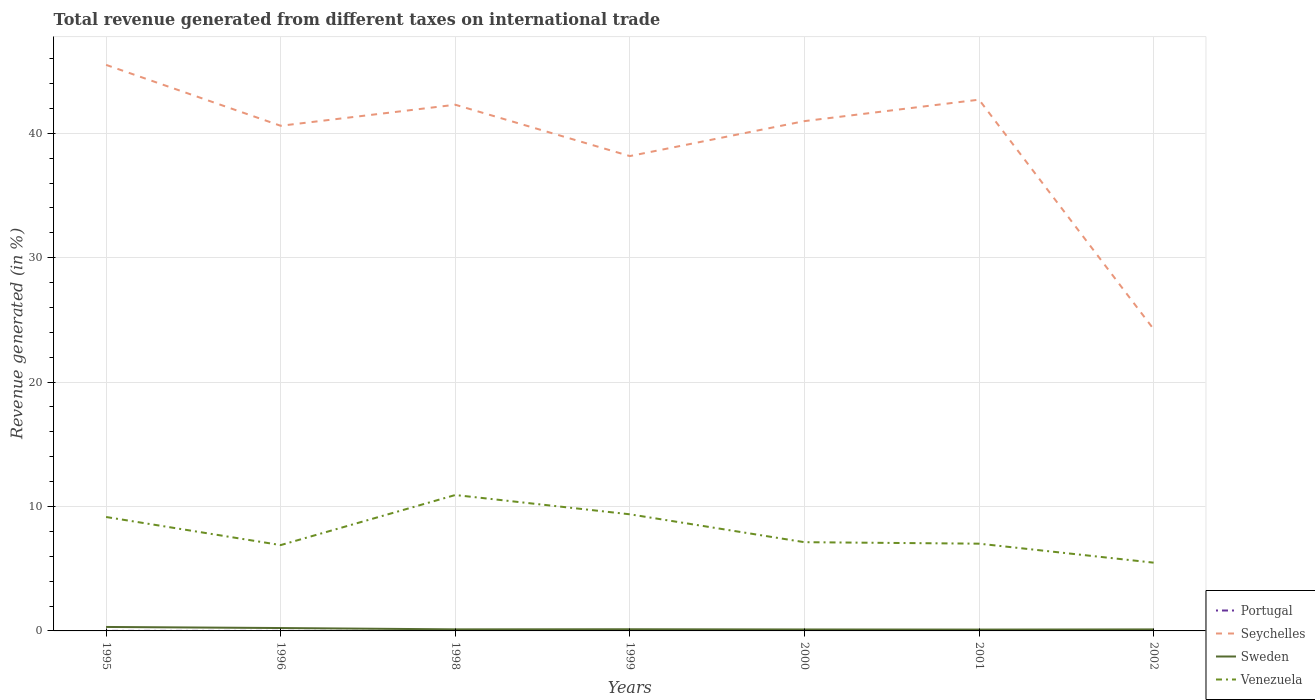How many different coloured lines are there?
Ensure brevity in your answer.  4. Is the number of lines equal to the number of legend labels?
Keep it short and to the point. Yes. Across all years, what is the maximum total revenue generated in Seychelles?
Your answer should be very brief. 24.26. In which year was the total revenue generated in Portugal maximum?
Ensure brevity in your answer.  2001. What is the total total revenue generated in Seychelles in the graph?
Give a very brief answer. -2.81. What is the difference between the highest and the second highest total revenue generated in Sweden?
Offer a terse response. 0.21. What is the difference between the highest and the lowest total revenue generated in Portugal?
Your response must be concise. 2. How many lines are there?
Keep it short and to the point. 4. How many legend labels are there?
Make the answer very short. 4. What is the title of the graph?
Give a very brief answer. Total revenue generated from different taxes on international trade. What is the label or title of the Y-axis?
Ensure brevity in your answer.  Revenue generated (in %). What is the Revenue generated (in %) of Portugal in 1995?
Offer a very short reply. 0. What is the Revenue generated (in %) of Seychelles in 1995?
Your answer should be compact. 45.5. What is the Revenue generated (in %) in Sweden in 1995?
Offer a very short reply. 0.32. What is the Revenue generated (in %) in Venezuela in 1995?
Give a very brief answer. 9.16. What is the Revenue generated (in %) in Portugal in 1996?
Give a very brief answer. 0. What is the Revenue generated (in %) of Seychelles in 1996?
Your response must be concise. 40.6. What is the Revenue generated (in %) in Sweden in 1996?
Your answer should be compact. 0.23. What is the Revenue generated (in %) in Venezuela in 1996?
Provide a short and direct response. 6.9. What is the Revenue generated (in %) of Portugal in 1998?
Make the answer very short. 0.01. What is the Revenue generated (in %) in Seychelles in 1998?
Give a very brief answer. 42.29. What is the Revenue generated (in %) in Sweden in 1998?
Keep it short and to the point. 0.13. What is the Revenue generated (in %) in Venezuela in 1998?
Provide a short and direct response. 10.92. What is the Revenue generated (in %) of Portugal in 1999?
Your answer should be compact. 0. What is the Revenue generated (in %) of Seychelles in 1999?
Keep it short and to the point. 38.17. What is the Revenue generated (in %) of Sweden in 1999?
Offer a very short reply. 0.13. What is the Revenue generated (in %) of Venezuela in 1999?
Give a very brief answer. 9.37. What is the Revenue generated (in %) in Portugal in 2000?
Offer a terse response. 0. What is the Revenue generated (in %) in Seychelles in 2000?
Your answer should be very brief. 40.98. What is the Revenue generated (in %) in Sweden in 2000?
Provide a short and direct response. 0.12. What is the Revenue generated (in %) in Venezuela in 2000?
Offer a very short reply. 7.13. What is the Revenue generated (in %) in Portugal in 2001?
Ensure brevity in your answer.  0. What is the Revenue generated (in %) of Seychelles in 2001?
Your answer should be very brief. 42.7. What is the Revenue generated (in %) in Sweden in 2001?
Your answer should be very brief. 0.11. What is the Revenue generated (in %) in Venezuela in 2001?
Ensure brevity in your answer.  7.01. What is the Revenue generated (in %) in Portugal in 2002?
Your response must be concise. 0. What is the Revenue generated (in %) in Seychelles in 2002?
Keep it short and to the point. 24.26. What is the Revenue generated (in %) in Sweden in 2002?
Offer a terse response. 0.12. What is the Revenue generated (in %) in Venezuela in 2002?
Keep it short and to the point. 5.49. Across all years, what is the maximum Revenue generated (in %) in Portugal?
Offer a terse response. 0.01. Across all years, what is the maximum Revenue generated (in %) in Seychelles?
Offer a terse response. 45.5. Across all years, what is the maximum Revenue generated (in %) of Sweden?
Provide a short and direct response. 0.32. Across all years, what is the maximum Revenue generated (in %) in Venezuela?
Offer a very short reply. 10.92. Across all years, what is the minimum Revenue generated (in %) in Portugal?
Keep it short and to the point. 0. Across all years, what is the minimum Revenue generated (in %) in Seychelles?
Give a very brief answer. 24.26. Across all years, what is the minimum Revenue generated (in %) in Sweden?
Your answer should be compact. 0.11. Across all years, what is the minimum Revenue generated (in %) of Venezuela?
Provide a short and direct response. 5.49. What is the total Revenue generated (in %) in Portugal in the graph?
Give a very brief answer. 0.02. What is the total Revenue generated (in %) in Seychelles in the graph?
Your answer should be very brief. 274.5. What is the total Revenue generated (in %) of Sweden in the graph?
Provide a succinct answer. 1.16. What is the total Revenue generated (in %) in Venezuela in the graph?
Give a very brief answer. 55.99. What is the difference between the Revenue generated (in %) in Portugal in 1995 and that in 1996?
Make the answer very short. 0. What is the difference between the Revenue generated (in %) of Seychelles in 1995 and that in 1996?
Provide a succinct answer. 4.89. What is the difference between the Revenue generated (in %) of Sweden in 1995 and that in 1996?
Offer a terse response. 0.09. What is the difference between the Revenue generated (in %) of Venezuela in 1995 and that in 1996?
Provide a short and direct response. 2.26. What is the difference between the Revenue generated (in %) in Portugal in 1995 and that in 1998?
Your answer should be very brief. -0. What is the difference between the Revenue generated (in %) in Seychelles in 1995 and that in 1998?
Your answer should be very brief. 3.2. What is the difference between the Revenue generated (in %) in Sweden in 1995 and that in 1998?
Make the answer very short. 0.19. What is the difference between the Revenue generated (in %) of Venezuela in 1995 and that in 1998?
Offer a terse response. -1.77. What is the difference between the Revenue generated (in %) in Portugal in 1995 and that in 1999?
Offer a terse response. 0. What is the difference between the Revenue generated (in %) in Seychelles in 1995 and that in 1999?
Provide a succinct answer. 7.33. What is the difference between the Revenue generated (in %) in Sweden in 1995 and that in 1999?
Offer a terse response. 0.18. What is the difference between the Revenue generated (in %) in Venezuela in 1995 and that in 1999?
Your response must be concise. -0.22. What is the difference between the Revenue generated (in %) of Portugal in 1995 and that in 2000?
Give a very brief answer. 0. What is the difference between the Revenue generated (in %) in Seychelles in 1995 and that in 2000?
Provide a succinct answer. 4.52. What is the difference between the Revenue generated (in %) of Sweden in 1995 and that in 2000?
Provide a short and direct response. 0.2. What is the difference between the Revenue generated (in %) in Venezuela in 1995 and that in 2000?
Your response must be concise. 2.02. What is the difference between the Revenue generated (in %) of Portugal in 1995 and that in 2001?
Give a very brief answer. 0. What is the difference between the Revenue generated (in %) of Seychelles in 1995 and that in 2001?
Keep it short and to the point. 2.8. What is the difference between the Revenue generated (in %) in Sweden in 1995 and that in 2001?
Give a very brief answer. 0.21. What is the difference between the Revenue generated (in %) in Venezuela in 1995 and that in 2001?
Give a very brief answer. 2.14. What is the difference between the Revenue generated (in %) in Portugal in 1995 and that in 2002?
Keep it short and to the point. 0. What is the difference between the Revenue generated (in %) of Seychelles in 1995 and that in 2002?
Ensure brevity in your answer.  21.24. What is the difference between the Revenue generated (in %) of Sweden in 1995 and that in 2002?
Provide a succinct answer. 0.2. What is the difference between the Revenue generated (in %) of Venezuela in 1995 and that in 2002?
Give a very brief answer. 3.67. What is the difference between the Revenue generated (in %) of Portugal in 1996 and that in 1998?
Make the answer very short. -0. What is the difference between the Revenue generated (in %) in Seychelles in 1996 and that in 1998?
Give a very brief answer. -1.69. What is the difference between the Revenue generated (in %) in Sweden in 1996 and that in 1998?
Ensure brevity in your answer.  0.11. What is the difference between the Revenue generated (in %) of Venezuela in 1996 and that in 1998?
Offer a very short reply. -4.02. What is the difference between the Revenue generated (in %) of Portugal in 1996 and that in 1999?
Your answer should be very brief. 0. What is the difference between the Revenue generated (in %) in Seychelles in 1996 and that in 1999?
Make the answer very short. 2.44. What is the difference between the Revenue generated (in %) in Sweden in 1996 and that in 1999?
Give a very brief answer. 0.1. What is the difference between the Revenue generated (in %) of Venezuela in 1996 and that in 1999?
Offer a terse response. -2.47. What is the difference between the Revenue generated (in %) in Portugal in 1996 and that in 2000?
Give a very brief answer. 0. What is the difference between the Revenue generated (in %) of Seychelles in 1996 and that in 2000?
Keep it short and to the point. -0.37. What is the difference between the Revenue generated (in %) of Sweden in 1996 and that in 2000?
Your answer should be compact. 0.12. What is the difference between the Revenue generated (in %) of Venezuela in 1996 and that in 2000?
Offer a terse response. -0.23. What is the difference between the Revenue generated (in %) in Portugal in 1996 and that in 2001?
Your answer should be compact. 0. What is the difference between the Revenue generated (in %) of Seychelles in 1996 and that in 2001?
Your answer should be compact. -2.1. What is the difference between the Revenue generated (in %) in Sweden in 1996 and that in 2001?
Offer a terse response. 0.12. What is the difference between the Revenue generated (in %) of Venezuela in 1996 and that in 2001?
Keep it short and to the point. -0.11. What is the difference between the Revenue generated (in %) in Portugal in 1996 and that in 2002?
Your answer should be very brief. 0. What is the difference between the Revenue generated (in %) of Seychelles in 1996 and that in 2002?
Give a very brief answer. 16.35. What is the difference between the Revenue generated (in %) in Venezuela in 1996 and that in 2002?
Ensure brevity in your answer.  1.41. What is the difference between the Revenue generated (in %) in Portugal in 1998 and that in 1999?
Provide a short and direct response. 0.01. What is the difference between the Revenue generated (in %) in Seychelles in 1998 and that in 1999?
Provide a succinct answer. 4.13. What is the difference between the Revenue generated (in %) of Sweden in 1998 and that in 1999?
Offer a terse response. -0.01. What is the difference between the Revenue generated (in %) in Venezuela in 1998 and that in 1999?
Your answer should be very brief. 1.55. What is the difference between the Revenue generated (in %) of Portugal in 1998 and that in 2000?
Offer a very short reply. 0. What is the difference between the Revenue generated (in %) of Seychelles in 1998 and that in 2000?
Offer a terse response. 1.32. What is the difference between the Revenue generated (in %) in Sweden in 1998 and that in 2000?
Your answer should be very brief. 0.01. What is the difference between the Revenue generated (in %) of Venezuela in 1998 and that in 2000?
Offer a terse response. 3.79. What is the difference between the Revenue generated (in %) in Portugal in 1998 and that in 2001?
Provide a succinct answer. 0.01. What is the difference between the Revenue generated (in %) in Seychelles in 1998 and that in 2001?
Your answer should be very brief. -0.41. What is the difference between the Revenue generated (in %) in Sweden in 1998 and that in 2001?
Your answer should be compact. 0.02. What is the difference between the Revenue generated (in %) in Venezuela in 1998 and that in 2001?
Provide a succinct answer. 3.91. What is the difference between the Revenue generated (in %) in Portugal in 1998 and that in 2002?
Offer a very short reply. 0.01. What is the difference between the Revenue generated (in %) in Seychelles in 1998 and that in 2002?
Your response must be concise. 18.04. What is the difference between the Revenue generated (in %) in Sweden in 1998 and that in 2002?
Make the answer very short. 0. What is the difference between the Revenue generated (in %) in Venezuela in 1998 and that in 2002?
Make the answer very short. 5.44. What is the difference between the Revenue generated (in %) in Portugal in 1999 and that in 2000?
Keep it short and to the point. -0. What is the difference between the Revenue generated (in %) in Seychelles in 1999 and that in 2000?
Your response must be concise. -2.81. What is the difference between the Revenue generated (in %) of Sweden in 1999 and that in 2000?
Your response must be concise. 0.02. What is the difference between the Revenue generated (in %) of Venezuela in 1999 and that in 2000?
Ensure brevity in your answer.  2.24. What is the difference between the Revenue generated (in %) of Portugal in 1999 and that in 2001?
Offer a very short reply. 0. What is the difference between the Revenue generated (in %) in Seychelles in 1999 and that in 2001?
Offer a very short reply. -4.53. What is the difference between the Revenue generated (in %) in Sweden in 1999 and that in 2001?
Your response must be concise. 0.03. What is the difference between the Revenue generated (in %) in Venezuela in 1999 and that in 2001?
Your response must be concise. 2.36. What is the difference between the Revenue generated (in %) of Portugal in 1999 and that in 2002?
Ensure brevity in your answer.  0. What is the difference between the Revenue generated (in %) in Seychelles in 1999 and that in 2002?
Your answer should be very brief. 13.91. What is the difference between the Revenue generated (in %) in Sweden in 1999 and that in 2002?
Your response must be concise. 0.01. What is the difference between the Revenue generated (in %) in Venezuela in 1999 and that in 2002?
Make the answer very short. 3.89. What is the difference between the Revenue generated (in %) in Portugal in 2000 and that in 2001?
Make the answer very short. 0. What is the difference between the Revenue generated (in %) in Seychelles in 2000 and that in 2001?
Provide a succinct answer. -1.72. What is the difference between the Revenue generated (in %) in Sweden in 2000 and that in 2001?
Offer a very short reply. 0.01. What is the difference between the Revenue generated (in %) of Venezuela in 2000 and that in 2001?
Make the answer very short. 0.12. What is the difference between the Revenue generated (in %) in Seychelles in 2000 and that in 2002?
Keep it short and to the point. 16.72. What is the difference between the Revenue generated (in %) in Sweden in 2000 and that in 2002?
Ensure brevity in your answer.  -0.01. What is the difference between the Revenue generated (in %) in Venezuela in 2000 and that in 2002?
Keep it short and to the point. 1.65. What is the difference between the Revenue generated (in %) of Portugal in 2001 and that in 2002?
Offer a terse response. -0. What is the difference between the Revenue generated (in %) of Seychelles in 2001 and that in 2002?
Make the answer very short. 18.45. What is the difference between the Revenue generated (in %) in Sweden in 2001 and that in 2002?
Offer a terse response. -0.01. What is the difference between the Revenue generated (in %) of Venezuela in 2001 and that in 2002?
Make the answer very short. 1.53. What is the difference between the Revenue generated (in %) in Portugal in 1995 and the Revenue generated (in %) in Seychelles in 1996?
Provide a succinct answer. -40.6. What is the difference between the Revenue generated (in %) of Portugal in 1995 and the Revenue generated (in %) of Sweden in 1996?
Provide a succinct answer. -0.23. What is the difference between the Revenue generated (in %) in Portugal in 1995 and the Revenue generated (in %) in Venezuela in 1996?
Provide a short and direct response. -6.9. What is the difference between the Revenue generated (in %) of Seychelles in 1995 and the Revenue generated (in %) of Sweden in 1996?
Your response must be concise. 45.27. What is the difference between the Revenue generated (in %) in Seychelles in 1995 and the Revenue generated (in %) in Venezuela in 1996?
Provide a succinct answer. 38.6. What is the difference between the Revenue generated (in %) in Sweden in 1995 and the Revenue generated (in %) in Venezuela in 1996?
Keep it short and to the point. -6.58. What is the difference between the Revenue generated (in %) in Portugal in 1995 and the Revenue generated (in %) in Seychelles in 1998?
Offer a terse response. -42.29. What is the difference between the Revenue generated (in %) in Portugal in 1995 and the Revenue generated (in %) in Sweden in 1998?
Give a very brief answer. -0.12. What is the difference between the Revenue generated (in %) of Portugal in 1995 and the Revenue generated (in %) of Venezuela in 1998?
Your answer should be very brief. -10.92. What is the difference between the Revenue generated (in %) of Seychelles in 1995 and the Revenue generated (in %) of Sweden in 1998?
Your answer should be compact. 45.37. What is the difference between the Revenue generated (in %) in Seychelles in 1995 and the Revenue generated (in %) in Venezuela in 1998?
Keep it short and to the point. 34.58. What is the difference between the Revenue generated (in %) in Sweden in 1995 and the Revenue generated (in %) in Venezuela in 1998?
Your answer should be very brief. -10.6. What is the difference between the Revenue generated (in %) in Portugal in 1995 and the Revenue generated (in %) in Seychelles in 1999?
Offer a very short reply. -38.16. What is the difference between the Revenue generated (in %) of Portugal in 1995 and the Revenue generated (in %) of Sweden in 1999?
Offer a very short reply. -0.13. What is the difference between the Revenue generated (in %) in Portugal in 1995 and the Revenue generated (in %) in Venezuela in 1999?
Your response must be concise. -9.37. What is the difference between the Revenue generated (in %) in Seychelles in 1995 and the Revenue generated (in %) in Sweden in 1999?
Give a very brief answer. 45.36. What is the difference between the Revenue generated (in %) in Seychelles in 1995 and the Revenue generated (in %) in Venezuela in 1999?
Keep it short and to the point. 36.12. What is the difference between the Revenue generated (in %) in Sweden in 1995 and the Revenue generated (in %) in Venezuela in 1999?
Your answer should be very brief. -9.06. What is the difference between the Revenue generated (in %) of Portugal in 1995 and the Revenue generated (in %) of Seychelles in 2000?
Provide a succinct answer. -40.97. What is the difference between the Revenue generated (in %) in Portugal in 1995 and the Revenue generated (in %) in Sweden in 2000?
Provide a short and direct response. -0.11. What is the difference between the Revenue generated (in %) in Portugal in 1995 and the Revenue generated (in %) in Venezuela in 2000?
Ensure brevity in your answer.  -7.13. What is the difference between the Revenue generated (in %) in Seychelles in 1995 and the Revenue generated (in %) in Sweden in 2000?
Ensure brevity in your answer.  45.38. What is the difference between the Revenue generated (in %) of Seychelles in 1995 and the Revenue generated (in %) of Venezuela in 2000?
Offer a terse response. 38.37. What is the difference between the Revenue generated (in %) in Sweden in 1995 and the Revenue generated (in %) in Venezuela in 2000?
Make the answer very short. -6.81. What is the difference between the Revenue generated (in %) of Portugal in 1995 and the Revenue generated (in %) of Seychelles in 2001?
Provide a succinct answer. -42.7. What is the difference between the Revenue generated (in %) of Portugal in 1995 and the Revenue generated (in %) of Sweden in 2001?
Make the answer very short. -0.1. What is the difference between the Revenue generated (in %) of Portugal in 1995 and the Revenue generated (in %) of Venezuela in 2001?
Offer a terse response. -7.01. What is the difference between the Revenue generated (in %) in Seychelles in 1995 and the Revenue generated (in %) in Sweden in 2001?
Offer a very short reply. 45.39. What is the difference between the Revenue generated (in %) in Seychelles in 1995 and the Revenue generated (in %) in Venezuela in 2001?
Your answer should be compact. 38.49. What is the difference between the Revenue generated (in %) of Sweden in 1995 and the Revenue generated (in %) of Venezuela in 2001?
Keep it short and to the point. -6.69. What is the difference between the Revenue generated (in %) in Portugal in 1995 and the Revenue generated (in %) in Seychelles in 2002?
Offer a terse response. -24.25. What is the difference between the Revenue generated (in %) in Portugal in 1995 and the Revenue generated (in %) in Sweden in 2002?
Provide a short and direct response. -0.12. What is the difference between the Revenue generated (in %) in Portugal in 1995 and the Revenue generated (in %) in Venezuela in 2002?
Offer a terse response. -5.48. What is the difference between the Revenue generated (in %) of Seychelles in 1995 and the Revenue generated (in %) of Sweden in 2002?
Your answer should be very brief. 45.38. What is the difference between the Revenue generated (in %) of Seychelles in 1995 and the Revenue generated (in %) of Venezuela in 2002?
Your answer should be compact. 40.01. What is the difference between the Revenue generated (in %) in Sweden in 1995 and the Revenue generated (in %) in Venezuela in 2002?
Ensure brevity in your answer.  -5.17. What is the difference between the Revenue generated (in %) in Portugal in 1996 and the Revenue generated (in %) in Seychelles in 1998?
Offer a terse response. -42.29. What is the difference between the Revenue generated (in %) in Portugal in 1996 and the Revenue generated (in %) in Sweden in 1998?
Keep it short and to the point. -0.12. What is the difference between the Revenue generated (in %) of Portugal in 1996 and the Revenue generated (in %) of Venezuela in 1998?
Provide a succinct answer. -10.92. What is the difference between the Revenue generated (in %) in Seychelles in 1996 and the Revenue generated (in %) in Sweden in 1998?
Give a very brief answer. 40.48. What is the difference between the Revenue generated (in %) in Seychelles in 1996 and the Revenue generated (in %) in Venezuela in 1998?
Your answer should be very brief. 29.68. What is the difference between the Revenue generated (in %) of Sweden in 1996 and the Revenue generated (in %) of Venezuela in 1998?
Your response must be concise. -10.69. What is the difference between the Revenue generated (in %) of Portugal in 1996 and the Revenue generated (in %) of Seychelles in 1999?
Your answer should be compact. -38.17. What is the difference between the Revenue generated (in %) of Portugal in 1996 and the Revenue generated (in %) of Sweden in 1999?
Ensure brevity in your answer.  -0.13. What is the difference between the Revenue generated (in %) of Portugal in 1996 and the Revenue generated (in %) of Venezuela in 1999?
Offer a terse response. -9.37. What is the difference between the Revenue generated (in %) of Seychelles in 1996 and the Revenue generated (in %) of Sweden in 1999?
Give a very brief answer. 40.47. What is the difference between the Revenue generated (in %) of Seychelles in 1996 and the Revenue generated (in %) of Venezuela in 1999?
Provide a short and direct response. 31.23. What is the difference between the Revenue generated (in %) in Sweden in 1996 and the Revenue generated (in %) in Venezuela in 1999?
Ensure brevity in your answer.  -9.14. What is the difference between the Revenue generated (in %) in Portugal in 1996 and the Revenue generated (in %) in Seychelles in 2000?
Your answer should be compact. -40.98. What is the difference between the Revenue generated (in %) of Portugal in 1996 and the Revenue generated (in %) of Sweden in 2000?
Your answer should be compact. -0.11. What is the difference between the Revenue generated (in %) in Portugal in 1996 and the Revenue generated (in %) in Venezuela in 2000?
Your response must be concise. -7.13. What is the difference between the Revenue generated (in %) in Seychelles in 1996 and the Revenue generated (in %) in Sweden in 2000?
Ensure brevity in your answer.  40.49. What is the difference between the Revenue generated (in %) of Seychelles in 1996 and the Revenue generated (in %) of Venezuela in 2000?
Offer a terse response. 33.47. What is the difference between the Revenue generated (in %) in Portugal in 1996 and the Revenue generated (in %) in Seychelles in 2001?
Provide a short and direct response. -42.7. What is the difference between the Revenue generated (in %) in Portugal in 1996 and the Revenue generated (in %) in Sweden in 2001?
Keep it short and to the point. -0.11. What is the difference between the Revenue generated (in %) of Portugal in 1996 and the Revenue generated (in %) of Venezuela in 2001?
Your response must be concise. -7.01. What is the difference between the Revenue generated (in %) of Seychelles in 1996 and the Revenue generated (in %) of Sweden in 2001?
Provide a succinct answer. 40.5. What is the difference between the Revenue generated (in %) of Seychelles in 1996 and the Revenue generated (in %) of Venezuela in 2001?
Your answer should be very brief. 33.59. What is the difference between the Revenue generated (in %) of Sweden in 1996 and the Revenue generated (in %) of Venezuela in 2001?
Offer a very short reply. -6.78. What is the difference between the Revenue generated (in %) of Portugal in 1996 and the Revenue generated (in %) of Seychelles in 2002?
Your answer should be compact. -24.25. What is the difference between the Revenue generated (in %) in Portugal in 1996 and the Revenue generated (in %) in Sweden in 2002?
Make the answer very short. -0.12. What is the difference between the Revenue generated (in %) of Portugal in 1996 and the Revenue generated (in %) of Venezuela in 2002?
Your answer should be very brief. -5.48. What is the difference between the Revenue generated (in %) in Seychelles in 1996 and the Revenue generated (in %) in Sweden in 2002?
Offer a very short reply. 40.48. What is the difference between the Revenue generated (in %) of Seychelles in 1996 and the Revenue generated (in %) of Venezuela in 2002?
Your answer should be compact. 35.12. What is the difference between the Revenue generated (in %) of Sweden in 1996 and the Revenue generated (in %) of Venezuela in 2002?
Offer a terse response. -5.25. What is the difference between the Revenue generated (in %) in Portugal in 1998 and the Revenue generated (in %) in Seychelles in 1999?
Provide a succinct answer. -38.16. What is the difference between the Revenue generated (in %) in Portugal in 1998 and the Revenue generated (in %) in Sweden in 1999?
Give a very brief answer. -0.13. What is the difference between the Revenue generated (in %) of Portugal in 1998 and the Revenue generated (in %) of Venezuela in 1999?
Provide a short and direct response. -9.37. What is the difference between the Revenue generated (in %) of Seychelles in 1998 and the Revenue generated (in %) of Sweden in 1999?
Your response must be concise. 42.16. What is the difference between the Revenue generated (in %) of Seychelles in 1998 and the Revenue generated (in %) of Venezuela in 1999?
Your answer should be very brief. 32.92. What is the difference between the Revenue generated (in %) in Sweden in 1998 and the Revenue generated (in %) in Venezuela in 1999?
Your answer should be compact. -9.25. What is the difference between the Revenue generated (in %) in Portugal in 1998 and the Revenue generated (in %) in Seychelles in 2000?
Your answer should be compact. -40.97. What is the difference between the Revenue generated (in %) of Portugal in 1998 and the Revenue generated (in %) of Sweden in 2000?
Provide a short and direct response. -0.11. What is the difference between the Revenue generated (in %) of Portugal in 1998 and the Revenue generated (in %) of Venezuela in 2000?
Your answer should be compact. -7.13. What is the difference between the Revenue generated (in %) in Seychelles in 1998 and the Revenue generated (in %) in Sweden in 2000?
Your answer should be very brief. 42.18. What is the difference between the Revenue generated (in %) of Seychelles in 1998 and the Revenue generated (in %) of Venezuela in 2000?
Give a very brief answer. 35.16. What is the difference between the Revenue generated (in %) in Sweden in 1998 and the Revenue generated (in %) in Venezuela in 2000?
Offer a very short reply. -7.01. What is the difference between the Revenue generated (in %) in Portugal in 1998 and the Revenue generated (in %) in Seychelles in 2001?
Offer a very short reply. -42.7. What is the difference between the Revenue generated (in %) of Portugal in 1998 and the Revenue generated (in %) of Sweden in 2001?
Provide a short and direct response. -0.1. What is the difference between the Revenue generated (in %) of Portugal in 1998 and the Revenue generated (in %) of Venezuela in 2001?
Keep it short and to the point. -7.01. What is the difference between the Revenue generated (in %) of Seychelles in 1998 and the Revenue generated (in %) of Sweden in 2001?
Your answer should be compact. 42.19. What is the difference between the Revenue generated (in %) in Seychelles in 1998 and the Revenue generated (in %) in Venezuela in 2001?
Offer a terse response. 35.28. What is the difference between the Revenue generated (in %) in Sweden in 1998 and the Revenue generated (in %) in Venezuela in 2001?
Your response must be concise. -6.89. What is the difference between the Revenue generated (in %) in Portugal in 1998 and the Revenue generated (in %) in Seychelles in 2002?
Keep it short and to the point. -24.25. What is the difference between the Revenue generated (in %) of Portugal in 1998 and the Revenue generated (in %) of Sweden in 2002?
Provide a short and direct response. -0.12. What is the difference between the Revenue generated (in %) in Portugal in 1998 and the Revenue generated (in %) in Venezuela in 2002?
Ensure brevity in your answer.  -5.48. What is the difference between the Revenue generated (in %) of Seychelles in 1998 and the Revenue generated (in %) of Sweden in 2002?
Make the answer very short. 42.17. What is the difference between the Revenue generated (in %) in Seychelles in 1998 and the Revenue generated (in %) in Venezuela in 2002?
Provide a succinct answer. 36.81. What is the difference between the Revenue generated (in %) in Sweden in 1998 and the Revenue generated (in %) in Venezuela in 2002?
Your answer should be compact. -5.36. What is the difference between the Revenue generated (in %) in Portugal in 1999 and the Revenue generated (in %) in Seychelles in 2000?
Give a very brief answer. -40.98. What is the difference between the Revenue generated (in %) of Portugal in 1999 and the Revenue generated (in %) of Sweden in 2000?
Provide a short and direct response. -0.11. What is the difference between the Revenue generated (in %) in Portugal in 1999 and the Revenue generated (in %) in Venezuela in 2000?
Offer a very short reply. -7.13. What is the difference between the Revenue generated (in %) in Seychelles in 1999 and the Revenue generated (in %) in Sweden in 2000?
Your response must be concise. 38.05. What is the difference between the Revenue generated (in %) in Seychelles in 1999 and the Revenue generated (in %) in Venezuela in 2000?
Keep it short and to the point. 31.04. What is the difference between the Revenue generated (in %) of Sweden in 1999 and the Revenue generated (in %) of Venezuela in 2000?
Keep it short and to the point. -7. What is the difference between the Revenue generated (in %) of Portugal in 1999 and the Revenue generated (in %) of Seychelles in 2001?
Ensure brevity in your answer.  -42.7. What is the difference between the Revenue generated (in %) of Portugal in 1999 and the Revenue generated (in %) of Sweden in 2001?
Keep it short and to the point. -0.11. What is the difference between the Revenue generated (in %) in Portugal in 1999 and the Revenue generated (in %) in Venezuela in 2001?
Provide a short and direct response. -7.01. What is the difference between the Revenue generated (in %) of Seychelles in 1999 and the Revenue generated (in %) of Sweden in 2001?
Offer a very short reply. 38.06. What is the difference between the Revenue generated (in %) of Seychelles in 1999 and the Revenue generated (in %) of Venezuela in 2001?
Offer a very short reply. 31.16. What is the difference between the Revenue generated (in %) of Sweden in 1999 and the Revenue generated (in %) of Venezuela in 2001?
Keep it short and to the point. -6.88. What is the difference between the Revenue generated (in %) of Portugal in 1999 and the Revenue generated (in %) of Seychelles in 2002?
Provide a short and direct response. -24.26. What is the difference between the Revenue generated (in %) of Portugal in 1999 and the Revenue generated (in %) of Sweden in 2002?
Your answer should be very brief. -0.12. What is the difference between the Revenue generated (in %) of Portugal in 1999 and the Revenue generated (in %) of Venezuela in 2002?
Provide a succinct answer. -5.49. What is the difference between the Revenue generated (in %) of Seychelles in 1999 and the Revenue generated (in %) of Sweden in 2002?
Your response must be concise. 38.05. What is the difference between the Revenue generated (in %) of Seychelles in 1999 and the Revenue generated (in %) of Venezuela in 2002?
Your answer should be very brief. 32.68. What is the difference between the Revenue generated (in %) of Sweden in 1999 and the Revenue generated (in %) of Venezuela in 2002?
Offer a terse response. -5.35. What is the difference between the Revenue generated (in %) in Portugal in 2000 and the Revenue generated (in %) in Seychelles in 2001?
Keep it short and to the point. -42.7. What is the difference between the Revenue generated (in %) in Portugal in 2000 and the Revenue generated (in %) in Sweden in 2001?
Keep it short and to the point. -0.11. What is the difference between the Revenue generated (in %) of Portugal in 2000 and the Revenue generated (in %) of Venezuela in 2001?
Provide a succinct answer. -7.01. What is the difference between the Revenue generated (in %) of Seychelles in 2000 and the Revenue generated (in %) of Sweden in 2001?
Ensure brevity in your answer.  40.87. What is the difference between the Revenue generated (in %) in Seychelles in 2000 and the Revenue generated (in %) in Venezuela in 2001?
Provide a succinct answer. 33.97. What is the difference between the Revenue generated (in %) in Sweden in 2000 and the Revenue generated (in %) in Venezuela in 2001?
Your answer should be compact. -6.9. What is the difference between the Revenue generated (in %) of Portugal in 2000 and the Revenue generated (in %) of Seychelles in 2002?
Provide a succinct answer. -24.25. What is the difference between the Revenue generated (in %) of Portugal in 2000 and the Revenue generated (in %) of Sweden in 2002?
Ensure brevity in your answer.  -0.12. What is the difference between the Revenue generated (in %) of Portugal in 2000 and the Revenue generated (in %) of Venezuela in 2002?
Make the answer very short. -5.49. What is the difference between the Revenue generated (in %) of Seychelles in 2000 and the Revenue generated (in %) of Sweden in 2002?
Your response must be concise. 40.86. What is the difference between the Revenue generated (in %) of Seychelles in 2000 and the Revenue generated (in %) of Venezuela in 2002?
Make the answer very short. 35.49. What is the difference between the Revenue generated (in %) of Sweden in 2000 and the Revenue generated (in %) of Venezuela in 2002?
Provide a succinct answer. -5.37. What is the difference between the Revenue generated (in %) of Portugal in 2001 and the Revenue generated (in %) of Seychelles in 2002?
Your answer should be compact. -24.26. What is the difference between the Revenue generated (in %) of Portugal in 2001 and the Revenue generated (in %) of Sweden in 2002?
Provide a succinct answer. -0.12. What is the difference between the Revenue generated (in %) of Portugal in 2001 and the Revenue generated (in %) of Venezuela in 2002?
Your answer should be compact. -5.49. What is the difference between the Revenue generated (in %) of Seychelles in 2001 and the Revenue generated (in %) of Sweden in 2002?
Ensure brevity in your answer.  42.58. What is the difference between the Revenue generated (in %) of Seychelles in 2001 and the Revenue generated (in %) of Venezuela in 2002?
Your answer should be compact. 37.22. What is the difference between the Revenue generated (in %) in Sweden in 2001 and the Revenue generated (in %) in Venezuela in 2002?
Make the answer very short. -5.38. What is the average Revenue generated (in %) in Portugal per year?
Make the answer very short. 0. What is the average Revenue generated (in %) in Seychelles per year?
Your answer should be very brief. 39.21. What is the average Revenue generated (in %) in Sweden per year?
Your answer should be very brief. 0.17. What is the average Revenue generated (in %) in Venezuela per year?
Make the answer very short. 8. In the year 1995, what is the difference between the Revenue generated (in %) of Portugal and Revenue generated (in %) of Seychelles?
Make the answer very short. -45.49. In the year 1995, what is the difference between the Revenue generated (in %) of Portugal and Revenue generated (in %) of Sweden?
Give a very brief answer. -0.31. In the year 1995, what is the difference between the Revenue generated (in %) of Portugal and Revenue generated (in %) of Venezuela?
Your answer should be compact. -9.15. In the year 1995, what is the difference between the Revenue generated (in %) in Seychelles and Revenue generated (in %) in Sweden?
Offer a terse response. 45.18. In the year 1995, what is the difference between the Revenue generated (in %) of Seychelles and Revenue generated (in %) of Venezuela?
Offer a terse response. 36.34. In the year 1995, what is the difference between the Revenue generated (in %) in Sweden and Revenue generated (in %) in Venezuela?
Provide a succinct answer. -8.84. In the year 1996, what is the difference between the Revenue generated (in %) in Portugal and Revenue generated (in %) in Seychelles?
Make the answer very short. -40.6. In the year 1996, what is the difference between the Revenue generated (in %) in Portugal and Revenue generated (in %) in Sweden?
Your response must be concise. -0.23. In the year 1996, what is the difference between the Revenue generated (in %) in Portugal and Revenue generated (in %) in Venezuela?
Provide a succinct answer. -6.9. In the year 1996, what is the difference between the Revenue generated (in %) of Seychelles and Revenue generated (in %) of Sweden?
Provide a short and direct response. 40.37. In the year 1996, what is the difference between the Revenue generated (in %) of Seychelles and Revenue generated (in %) of Venezuela?
Your answer should be very brief. 33.7. In the year 1996, what is the difference between the Revenue generated (in %) in Sweden and Revenue generated (in %) in Venezuela?
Offer a terse response. -6.67. In the year 1998, what is the difference between the Revenue generated (in %) of Portugal and Revenue generated (in %) of Seychelles?
Provide a succinct answer. -42.29. In the year 1998, what is the difference between the Revenue generated (in %) of Portugal and Revenue generated (in %) of Sweden?
Keep it short and to the point. -0.12. In the year 1998, what is the difference between the Revenue generated (in %) in Portugal and Revenue generated (in %) in Venezuela?
Offer a terse response. -10.92. In the year 1998, what is the difference between the Revenue generated (in %) in Seychelles and Revenue generated (in %) in Sweden?
Ensure brevity in your answer.  42.17. In the year 1998, what is the difference between the Revenue generated (in %) of Seychelles and Revenue generated (in %) of Venezuela?
Give a very brief answer. 31.37. In the year 1998, what is the difference between the Revenue generated (in %) in Sweden and Revenue generated (in %) in Venezuela?
Offer a terse response. -10.8. In the year 1999, what is the difference between the Revenue generated (in %) of Portugal and Revenue generated (in %) of Seychelles?
Offer a terse response. -38.17. In the year 1999, what is the difference between the Revenue generated (in %) of Portugal and Revenue generated (in %) of Sweden?
Ensure brevity in your answer.  -0.13. In the year 1999, what is the difference between the Revenue generated (in %) in Portugal and Revenue generated (in %) in Venezuela?
Give a very brief answer. -9.37. In the year 1999, what is the difference between the Revenue generated (in %) of Seychelles and Revenue generated (in %) of Sweden?
Offer a very short reply. 38.03. In the year 1999, what is the difference between the Revenue generated (in %) of Seychelles and Revenue generated (in %) of Venezuela?
Keep it short and to the point. 28.79. In the year 1999, what is the difference between the Revenue generated (in %) in Sweden and Revenue generated (in %) in Venezuela?
Your response must be concise. -9.24. In the year 2000, what is the difference between the Revenue generated (in %) of Portugal and Revenue generated (in %) of Seychelles?
Offer a very short reply. -40.98. In the year 2000, what is the difference between the Revenue generated (in %) in Portugal and Revenue generated (in %) in Sweden?
Ensure brevity in your answer.  -0.11. In the year 2000, what is the difference between the Revenue generated (in %) of Portugal and Revenue generated (in %) of Venezuela?
Provide a succinct answer. -7.13. In the year 2000, what is the difference between the Revenue generated (in %) in Seychelles and Revenue generated (in %) in Sweden?
Your answer should be very brief. 40.86. In the year 2000, what is the difference between the Revenue generated (in %) in Seychelles and Revenue generated (in %) in Venezuela?
Offer a terse response. 33.85. In the year 2000, what is the difference between the Revenue generated (in %) of Sweden and Revenue generated (in %) of Venezuela?
Your answer should be compact. -7.02. In the year 2001, what is the difference between the Revenue generated (in %) of Portugal and Revenue generated (in %) of Seychelles?
Your response must be concise. -42.7. In the year 2001, what is the difference between the Revenue generated (in %) of Portugal and Revenue generated (in %) of Sweden?
Make the answer very short. -0.11. In the year 2001, what is the difference between the Revenue generated (in %) of Portugal and Revenue generated (in %) of Venezuela?
Keep it short and to the point. -7.01. In the year 2001, what is the difference between the Revenue generated (in %) of Seychelles and Revenue generated (in %) of Sweden?
Provide a succinct answer. 42.59. In the year 2001, what is the difference between the Revenue generated (in %) of Seychelles and Revenue generated (in %) of Venezuela?
Make the answer very short. 35.69. In the year 2001, what is the difference between the Revenue generated (in %) of Sweden and Revenue generated (in %) of Venezuela?
Give a very brief answer. -6.91. In the year 2002, what is the difference between the Revenue generated (in %) in Portugal and Revenue generated (in %) in Seychelles?
Offer a terse response. -24.26. In the year 2002, what is the difference between the Revenue generated (in %) in Portugal and Revenue generated (in %) in Sweden?
Keep it short and to the point. -0.12. In the year 2002, what is the difference between the Revenue generated (in %) of Portugal and Revenue generated (in %) of Venezuela?
Offer a very short reply. -5.49. In the year 2002, what is the difference between the Revenue generated (in %) of Seychelles and Revenue generated (in %) of Sweden?
Your response must be concise. 24.13. In the year 2002, what is the difference between the Revenue generated (in %) of Seychelles and Revenue generated (in %) of Venezuela?
Make the answer very short. 18.77. In the year 2002, what is the difference between the Revenue generated (in %) in Sweden and Revenue generated (in %) in Venezuela?
Offer a terse response. -5.37. What is the ratio of the Revenue generated (in %) in Portugal in 1995 to that in 1996?
Give a very brief answer. 1.7. What is the ratio of the Revenue generated (in %) of Seychelles in 1995 to that in 1996?
Provide a succinct answer. 1.12. What is the ratio of the Revenue generated (in %) in Sweden in 1995 to that in 1996?
Make the answer very short. 1.37. What is the ratio of the Revenue generated (in %) of Venezuela in 1995 to that in 1996?
Your answer should be compact. 1.33. What is the ratio of the Revenue generated (in %) of Portugal in 1995 to that in 1998?
Ensure brevity in your answer.  0.66. What is the ratio of the Revenue generated (in %) of Seychelles in 1995 to that in 1998?
Keep it short and to the point. 1.08. What is the ratio of the Revenue generated (in %) of Sweden in 1995 to that in 1998?
Your answer should be compact. 2.54. What is the ratio of the Revenue generated (in %) in Venezuela in 1995 to that in 1998?
Offer a very short reply. 0.84. What is the ratio of the Revenue generated (in %) in Portugal in 1995 to that in 1999?
Your answer should be compact. 3.19. What is the ratio of the Revenue generated (in %) in Seychelles in 1995 to that in 1999?
Offer a terse response. 1.19. What is the ratio of the Revenue generated (in %) of Sweden in 1995 to that in 1999?
Keep it short and to the point. 2.38. What is the ratio of the Revenue generated (in %) in Venezuela in 1995 to that in 1999?
Keep it short and to the point. 0.98. What is the ratio of the Revenue generated (in %) of Portugal in 1995 to that in 2000?
Keep it short and to the point. 2.79. What is the ratio of the Revenue generated (in %) in Seychelles in 1995 to that in 2000?
Your response must be concise. 1.11. What is the ratio of the Revenue generated (in %) in Sweden in 1995 to that in 2000?
Give a very brief answer. 2.75. What is the ratio of the Revenue generated (in %) in Venezuela in 1995 to that in 2000?
Your answer should be compact. 1.28. What is the ratio of the Revenue generated (in %) of Portugal in 1995 to that in 2001?
Provide a succinct answer. 4.13. What is the ratio of the Revenue generated (in %) of Seychelles in 1995 to that in 2001?
Give a very brief answer. 1.07. What is the ratio of the Revenue generated (in %) in Sweden in 1995 to that in 2001?
Your response must be concise. 2.95. What is the ratio of the Revenue generated (in %) in Venezuela in 1995 to that in 2001?
Your response must be concise. 1.31. What is the ratio of the Revenue generated (in %) of Portugal in 1995 to that in 2002?
Ensure brevity in your answer.  4.03. What is the ratio of the Revenue generated (in %) of Seychelles in 1995 to that in 2002?
Ensure brevity in your answer.  1.88. What is the ratio of the Revenue generated (in %) in Sweden in 1995 to that in 2002?
Provide a succinct answer. 2.62. What is the ratio of the Revenue generated (in %) in Venezuela in 1995 to that in 2002?
Provide a short and direct response. 1.67. What is the ratio of the Revenue generated (in %) of Portugal in 1996 to that in 1998?
Make the answer very short. 0.39. What is the ratio of the Revenue generated (in %) of Sweden in 1996 to that in 1998?
Make the answer very short. 1.85. What is the ratio of the Revenue generated (in %) of Venezuela in 1996 to that in 1998?
Provide a short and direct response. 0.63. What is the ratio of the Revenue generated (in %) of Portugal in 1996 to that in 1999?
Provide a succinct answer. 1.88. What is the ratio of the Revenue generated (in %) of Seychelles in 1996 to that in 1999?
Ensure brevity in your answer.  1.06. What is the ratio of the Revenue generated (in %) in Sweden in 1996 to that in 1999?
Your response must be concise. 1.73. What is the ratio of the Revenue generated (in %) in Venezuela in 1996 to that in 1999?
Offer a terse response. 0.74. What is the ratio of the Revenue generated (in %) of Portugal in 1996 to that in 2000?
Your answer should be compact. 1.64. What is the ratio of the Revenue generated (in %) of Seychelles in 1996 to that in 2000?
Keep it short and to the point. 0.99. What is the ratio of the Revenue generated (in %) in Sweden in 1996 to that in 2000?
Give a very brief answer. 2. What is the ratio of the Revenue generated (in %) of Venezuela in 1996 to that in 2000?
Provide a succinct answer. 0.97. What is the ratio of the Revenue generated (in %) of Portugal in 1996 to that in 2001?
Your response must be concise. 2.43. What is the ratio of the Revenue generated (in %) of Seychelles in 1996 to that in 2001?
Provide a succinct answer. 0.95. What is the ratio of the Revenue generated (in %) in Sweden in 1996 to that in 2001?
Offer a very short reply. 2.15. What is the ratio of the Revenue generated (in %) of Venezuela in 1996 to that in 2001?
Provide a short and direct response. 0.98. What is the ratio of the Revenue generated (in %) of Portugal in 1996 to that in 2002?
Your answer should be compact. 2.37. What is the ratio of the Revenue generated (in %) in Seychelles in 1996 to that in 2002?
Ensure brevity in your answer.  1.67. What is the ratio of the Revenue generated (in %) in Sweden in 1996 to that in 2002?
Your response must be concise. 1.91. What is the ratio of the Revenue generated (in %) of Venezuela in 1996 to that in 2002?
Offer a terse response. 1.26. What is the ratio of the Revenue generated (in %) of Portugal in 1998 to that in 1999?
Your answer should be compact. 4.83. What is the ratio of the Revenue generated (in %) in Seychelles in 1998 to that in 1999?
Offer a terse response. 1.11. What is the ratio of the Revenue generated (in %) of Sweden in 1998 to that in 1999?
Ensure brevity in your answer.  0.94. What is the ratio of the Revenue generated (in %) of Venezuela in 1998 to that in 1999?
Your answer should be very brief. 1.17. What is the ratio of the Revenue generated (in %) of Portugal in 1998 to that in 2000?
Make the answer very short. 4.23. What is the ratio of the Revenue generated (in %) in Seychelles in 1998 to that in 2000?
Ensure brevity in your answer.  1.03. What is the ratio of the Revenue generated (in %) in Sweden in 1998 to that in 2000?
Provide a succinct answer. 1.08. What is the ratio of the Revenue generated (in %) in Venezuela in 1998 to that in 2000?
Make the answer very short. 1.53. What is the ratio of the Revenue generated (in %) in Portugal in 1998 to that in 2001?
Give a very brief answer. 6.26. What is the ratio of the Revenue generated (in %) in Seychelles in 1998 to that in 2001?
Your answer should be very brief. 0.99. What is the ratio of the Revenue generated (in %) of Sweden in 1998 to that in 2001?
Give a very brief answer. 1.16. What is the ratio of the Revenue generated (in %) of Venezuela in 1998 to that in 2001?
Give a very brief answer. 1.56. What is the ratio of the Revenue generated (in %) of Portugal in 1998 to that in 2002?
Keep it short and to the point. 6.11. What is the ratio of the Revenue generated (in %) of Seychelles in 1998 to that in 2002?
Your answer should be very brief. 1.74. What is the ratio of the Revenue generated (in %) of Sweden in 1998 to that in 2002?
Give a very brief answer. 1.03. What is the ratio of the Revenue generated (in %) of Venezuela in 1998 to that in 2002?
Make the answer very short. 1.99. What is the ratio of the Revenue generated (in %) of Portugal in 1999 to that in 2000?
Keep it short and to the point. 0.88. What is the ratio of the Revenue generated (in %) of Seychelles in 1999 to that in 2000?
Offer a very short reply. 0.93. What is the ratio of the Revenue generated (in %) of Sweden in 1999 to that in 2000?
Your response must be concise. 1.16. What is the ratio of the Revenue generated (in %) of Venezuela in 1999 to that in 2000?
Keep it short and to the point. 1.31. What is the ratio of the Revenue generated (in %) of Portugal in 1999 to that in 2001?
Provide a short and direct response. 1.3. What is the ratio of the Revenue generated (in %) of Seychelles in 1999 to that in 2001?
Offer a terse response. 0.89. What is the ratio of the Revenue generated (in %) in Sweden in 1999 to that in 2001?
Ensure brevity in your answer.  1.24. What is the ratio of the Revenue generated (in %) in Venezuela in 1999 to that in 2001?
Your response must be concise. 1.34. What is the ratio of the Revenue generated (in %) of Portugal in 1999 to that in 2002?
Ensure brevity in your answer.  1.26. What is the ratio of the Revenue generated (in %) in Seychelles in 1999 to that in 2002?
Offer a terse response. 1.57. What is the ratio of the Revenue generated (in %) in Sweden in 1999 to that in 2002?
Your response must be concise. 1.1. What is the ratio of the Revenue generated (in %) in Venezuela in 1999 to that in 2002?
Keep it short and to the point. 1.71. What is the ratio of the Revenue generated (in %) of Portugal in 2000 to that in 2001?
Offer a terse response. 1.48. What is the ratio of the Revenue generated (in %) in Seychelles in 2000 to that in 2001?
Give a very brief answer. 0.96. What is the ratio of the Revenue generated (in %) of Sweden in 2000 to that in 2001?
Your response must be concise. 1.08. What is the ratio of the Revenue generated (in %) of Venezuela in 2000 to that in 2001?
Your response must be concise. 1.02. What is the ratio of the Revenue generated (in %) of Portugal in 2000 to that in 2002?
Your response must be concise. 1.44. What is the ratio of the Revenue generated (in %) of Seychelles in 2000 to that in 2002?
Your answer should be very brief. 1.69. What is the ratio of the Revenue generated (in %) of Sweden in 2000 to that in 2002?
Ensure brevity in your answer.  0.96. What is the ratio of the Revenue generated (in %) in Portugal in 2001 to that in 2002?
Keep it short and to the point. 0.98. What is the ratio of the Revenue generated (in %) of Seychelles in 2001 to that in 2002?
Offer a terse response. 1.76. What is the ratio of the Revenue generated (in %) in Sweden in 2001 to that in 2002?
Your response must be concise. 0.89. What is the ratio of the Revenue generated (in %) in Venezuela in 2001 to that in 2002?
Ensure brevity in your answer.  1.28. What is the difference between the highest and the second highest Revenue generated (in %) of Portugal?
Your answer should be compact. 0. What is the difference between the highest and the second highest Revenue generated (in %) of Seychelles?
Provide a short and direct response. 2.8. What is the difference between the highest and the second highest Revenue generated (in %) in Sweden?
Keep it short and to the point. 0.09. What is the difference between the highest and the second highest Revenue generated (in %) in Venezuela?
Offer a very short reply. 1.55. What is the difference between the highest and the lowest Revenue generated (in %) of Portugal?
Provide a short and direct response. 0.01. What is the difference between the highest and the lowest Revenue generated (in %) in Seychelles?
Provide a short and direct response. 21.24. What is the difference between the highest and the lowest Revenue generated (in %) in Sweden?
Your answer should be very brief. 0.21. What is the difference between the highest and the lowest Revenue generated (in %) of Venezuela?
Ensure brevity in your answer.  5.44. 